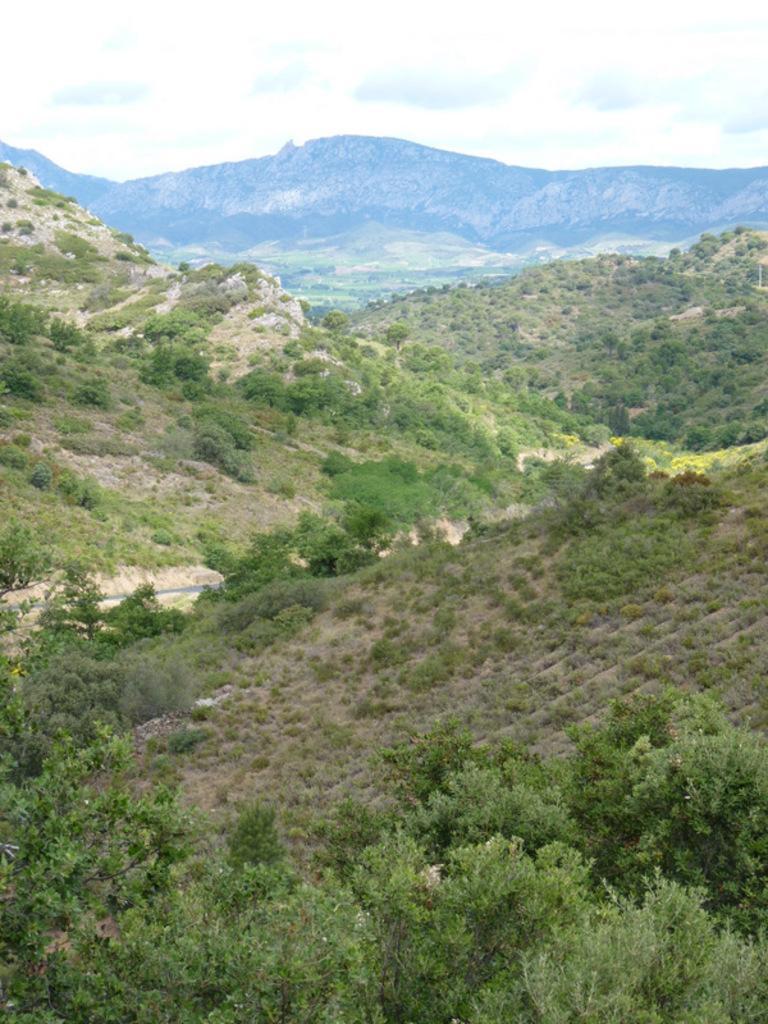Could you give a brief overview of what you see in this image? In this image we can see a group of trees, mountains. In the background, we can see the sky. 